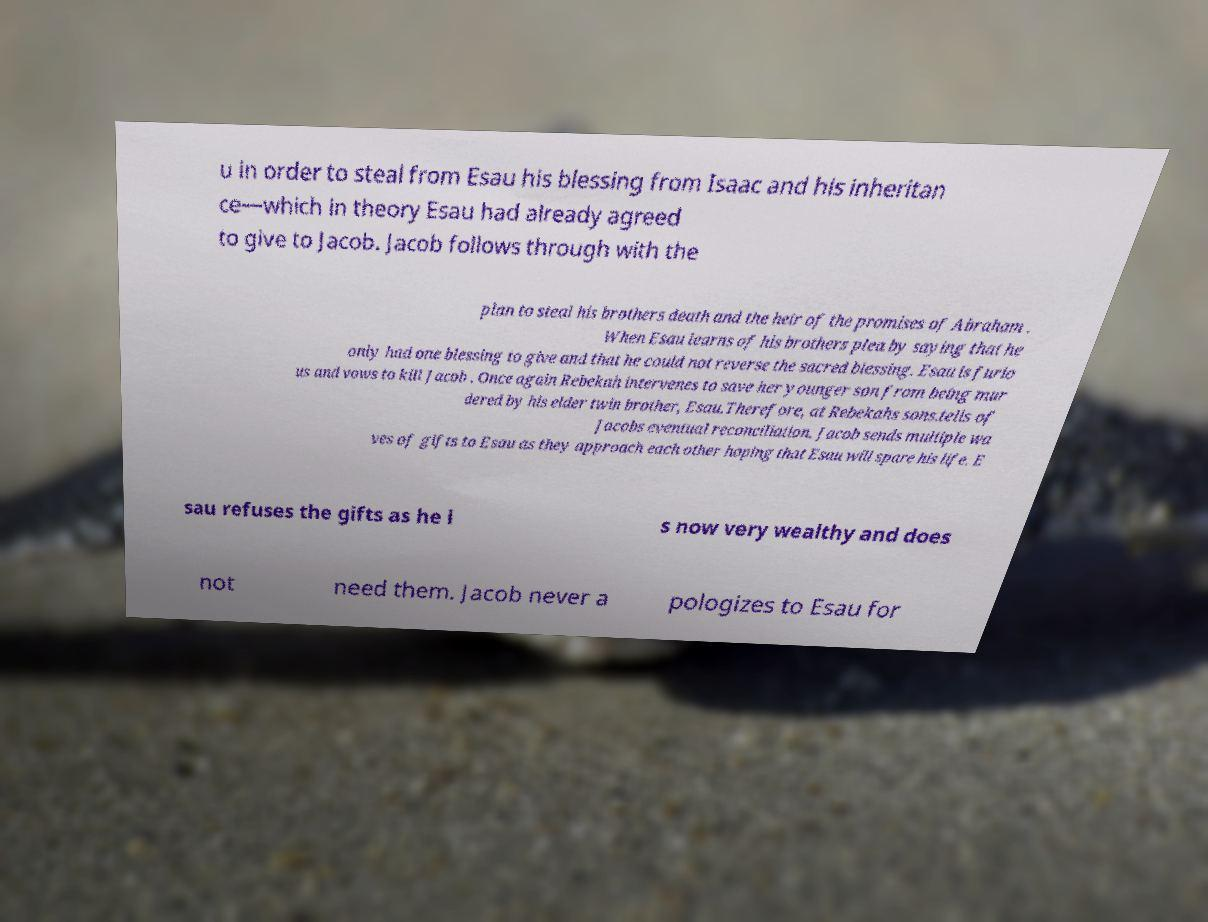Can you accurately transcribe the text from the provided image for me? u in order to steal from Esau his blessing from Isaac and his inheritan ce—which in theory Esau had already agreed to give to Jacob. Jacob follows through with the plan to steal his brothers death and the heir of the promises of Abraham . When Esau learns of his brothers plea by saying that he only had one blessing to give and that he could not reverse the sacred blessing. Esau is furio us and vows to kill Jacob . Once again Rebekah intervenes to save her younger son from being mur dered by his elder twin brother, Esau.Therefore, at Rebekahs sons.tells of Jacobs eventual reconciliation. Jacob sends multiple wa ves of gifts to Esau as they approach each other hoping that Esau will spare his life. E sau refuses the gifts as he i s now very wealthy and does not need them. Jacob never a pologizes to Esau for 